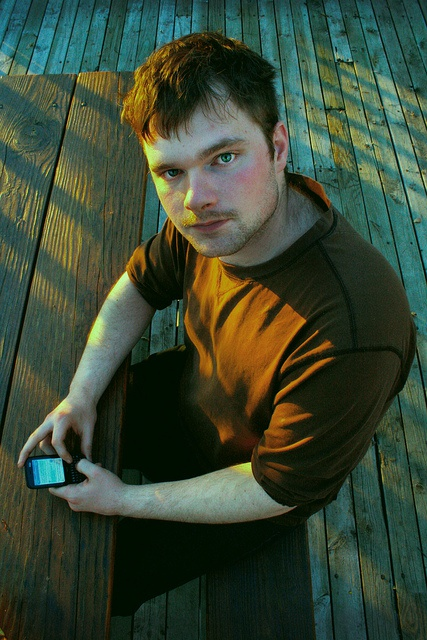Describe the objects in this image and their specific colors. I can see people in black, gray, brown, and darkgray tones, dining table in black, darkgreen, and teal tones, bench in black, teal, and darkgreen tones, and cell phone in black, turquoise, teal, and lightblue tones in this image. 